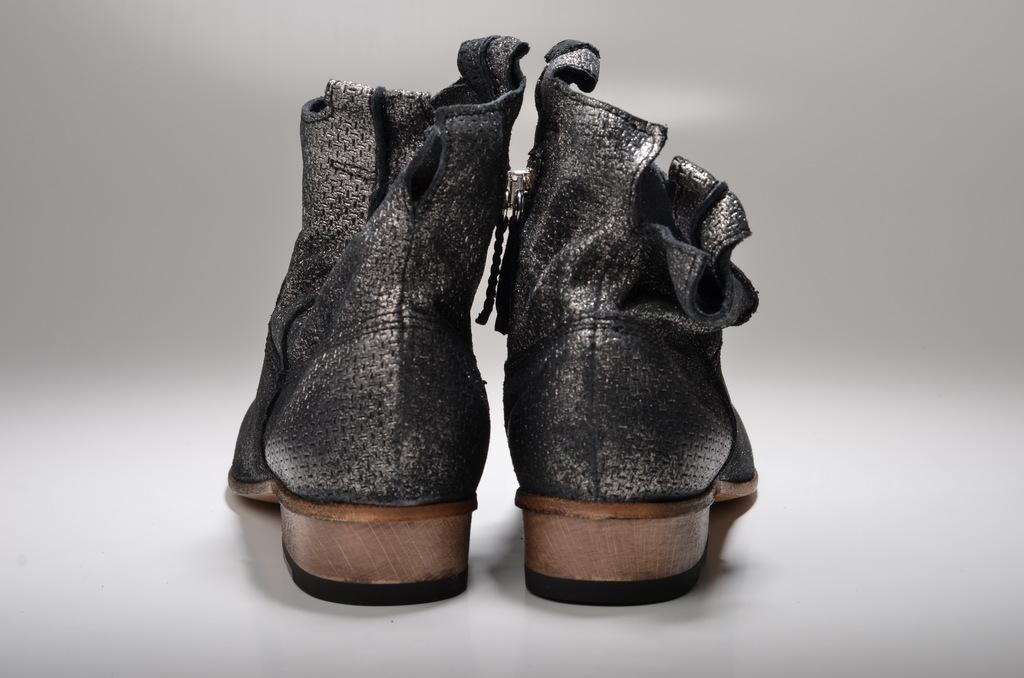How would you summarize this image in a sentence or two? In this picture I can observe shoes in the middle of the picture. These are in black and brown color. The background is in white color. 